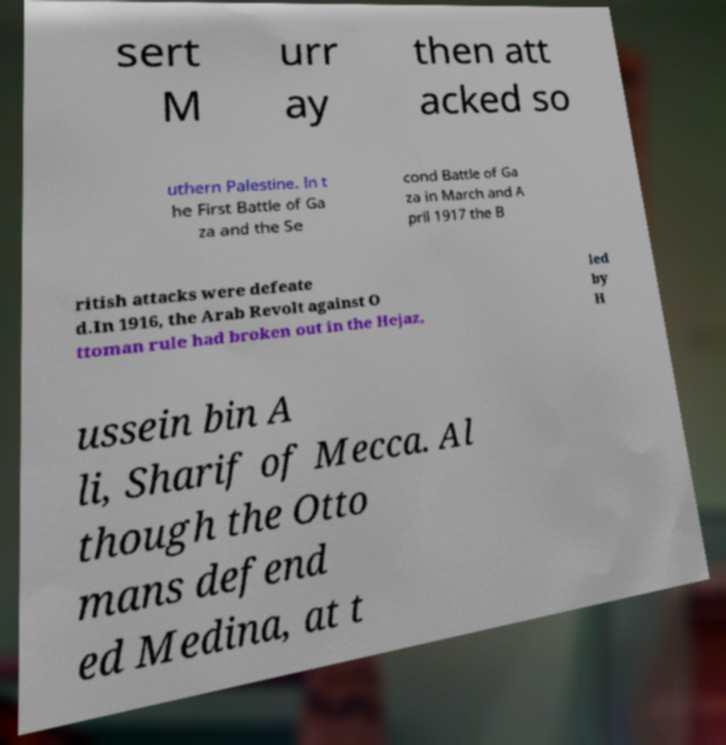Can you read and provide the text displayed in the image?This photo seems to have some interesting text. Can you extract and type it out for me? sert M urr ay then att acked so uthern Palestine. In t he First Battle of Ga za and the Se cond Battle of Ga za in March and A pril 1917 the B ritish attacks were defeate d.In 1916, the Arab Revolt against O ttoman rule had broken out in the Hejaz, led by H ussein bin A li, Sharif of Mecca. Al though the Otto mans defend ed Medina, at t 